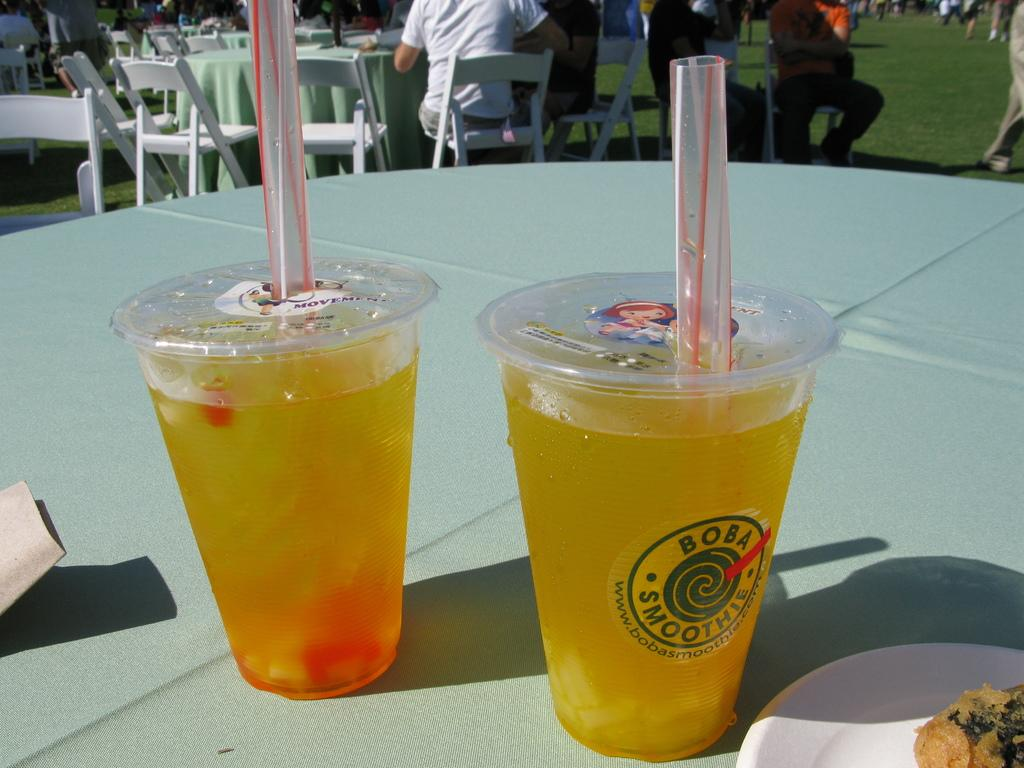What can be seen in the image related to beverages? There are two drinks in the image, and they have straws in them. What is located on the right side of the image? There is a white plate on the right side of the image. Where are the drinks and plate situated? The objects are on a table. What type of hobbies can be seen being practiced in the image? There are no hobbies being practiced in the image; it only shows two drinks with straws, a white plate, and a table. Can you see a hammer or club in the image? No, there is no hammer or club present in the image. 